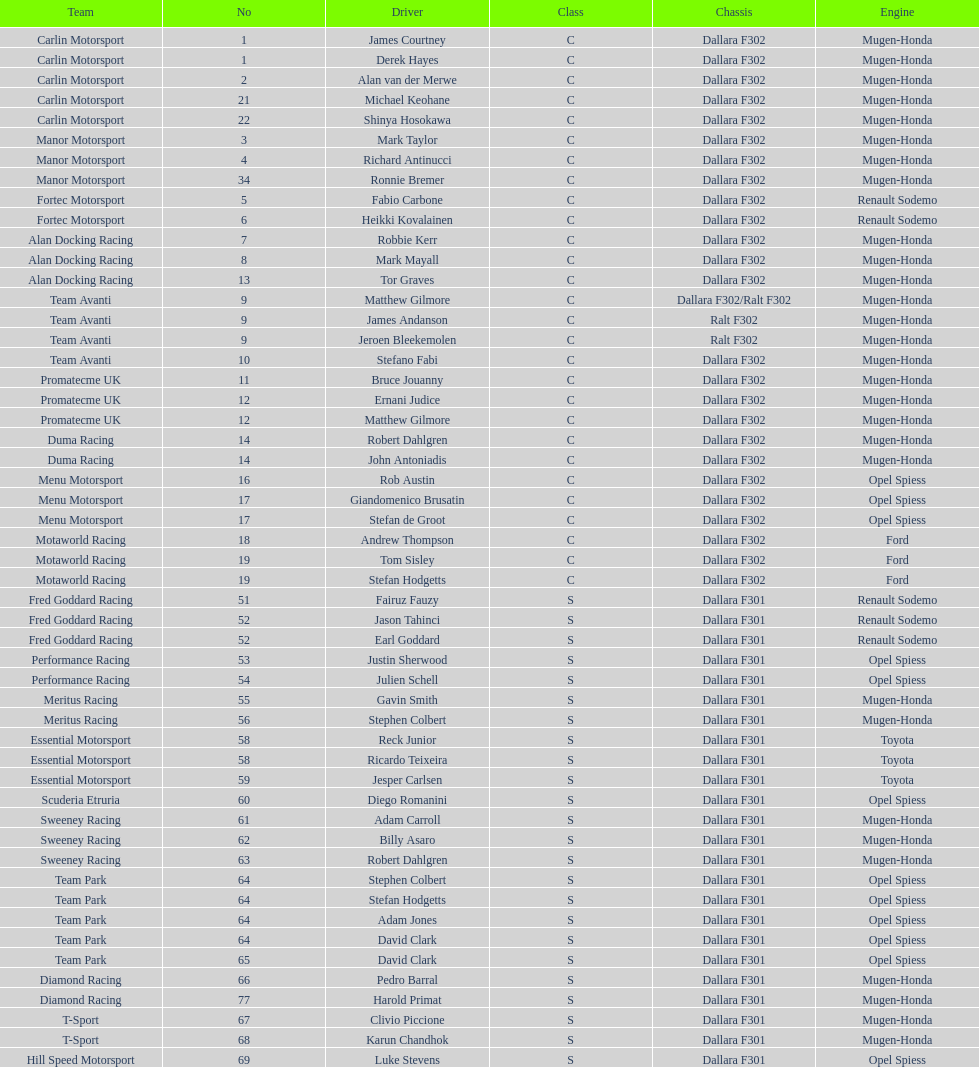What is the number of teams that had drivers all from the same country? 4. 